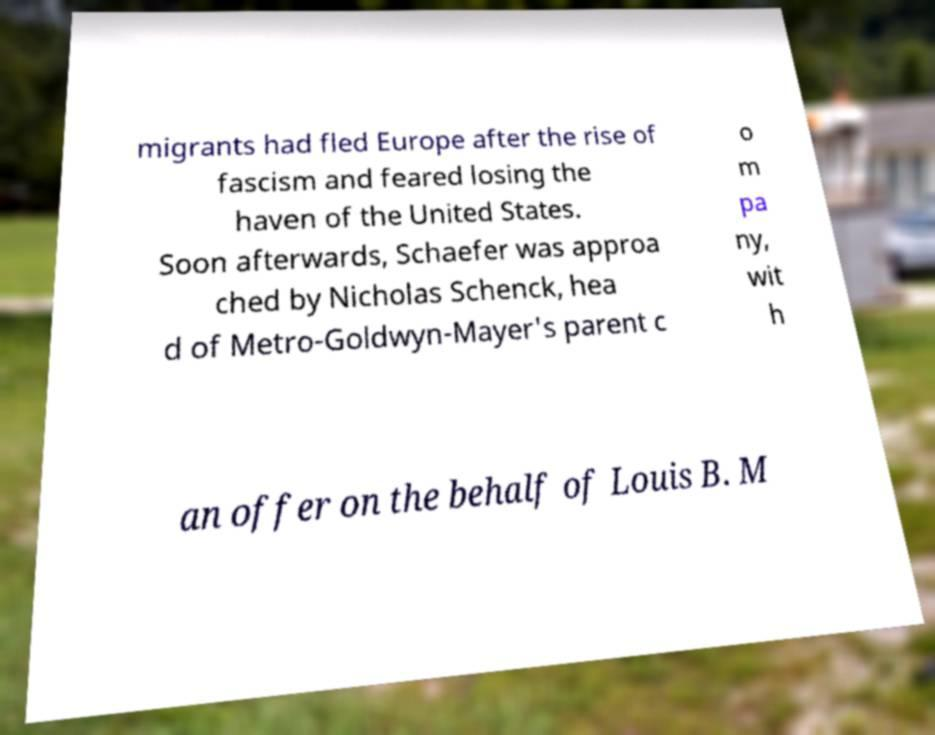There's text embedded in this image that I need extracted. Can you transcribe it verbatim? migrants had fled Europe after the rise of fascism and feared losing the haven of the United States. Soon afterwards, Schaefer was approa ched by Nicholas Schenck, hea d of Metro-Goldwyn-Mayer's parent c o m pa ny, wit h an offer on the behalf of Louis B. M 